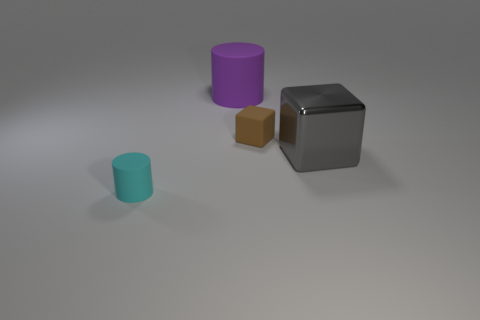What number of other things are the same size as the rubber cube? There is one object, the brown cube, which appears to be the same size as the rubber cube in the image. 